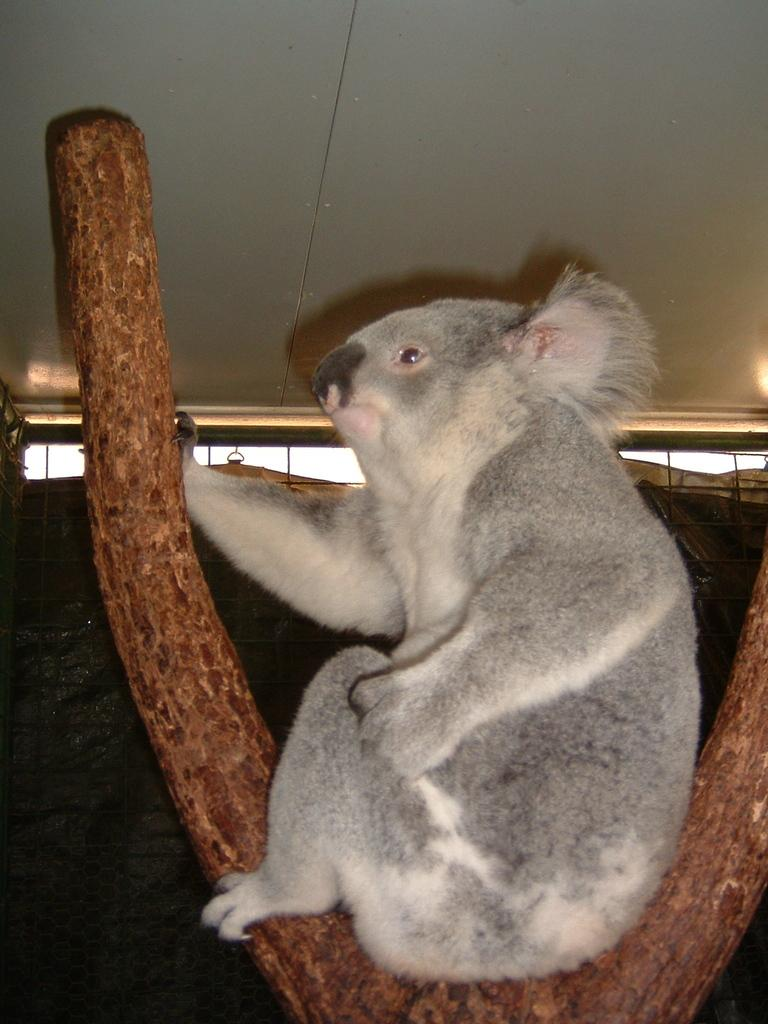What type of animal is in the image? The type of animal cannot be determined from the provided facts. Where is the animal located in the image? The animal is on a wooden surface. What can be seen in the background of the image? There are windows visible in the background of the image. What color is the sock that the animal is wearing in the image? There is no sock or indication of clothing on the animal in the image. What scene is depicted in the image? The scene cannot be determined from the provided facts; we only know that there is an animal on a wooden surface with windows visible in the background. 